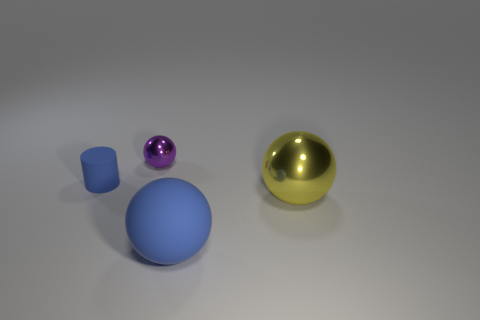Add 4 small blue things. How many objects exist? 8 Subtract all spheres. How many objects are left? 1 Subtract all tiny yellow shiny spheres. Subtract all purple balls. How many objects are left? 3 Add 4 big blue matte objects. How many big blue matte objects are left? 5 Add 1 cylinders. How many cylinders exist? 2 Subtract 0 yellow cylinders. How many objects are left? 4 